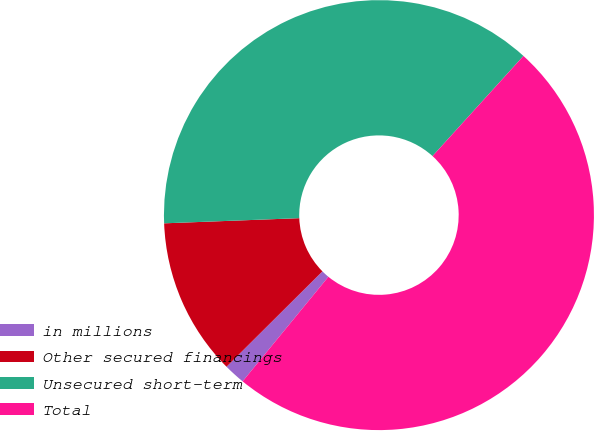<chart> <loc_0><loc_0><loc_500><loc_500><pie_chart><fcel>in millions<fcel>Other secured financings<fcel>Unsecured short-term<fcel>Total<nl><fcel>1.61%<fcel>11.85%<fcel>37.34%<fcel>49.2%<nl></chart> 